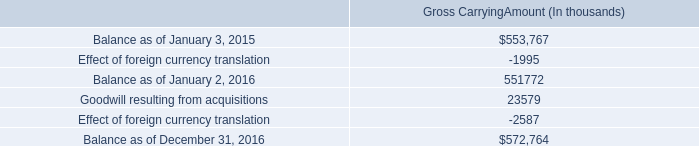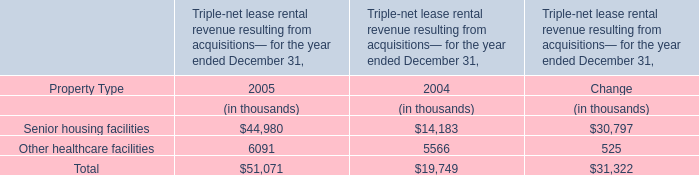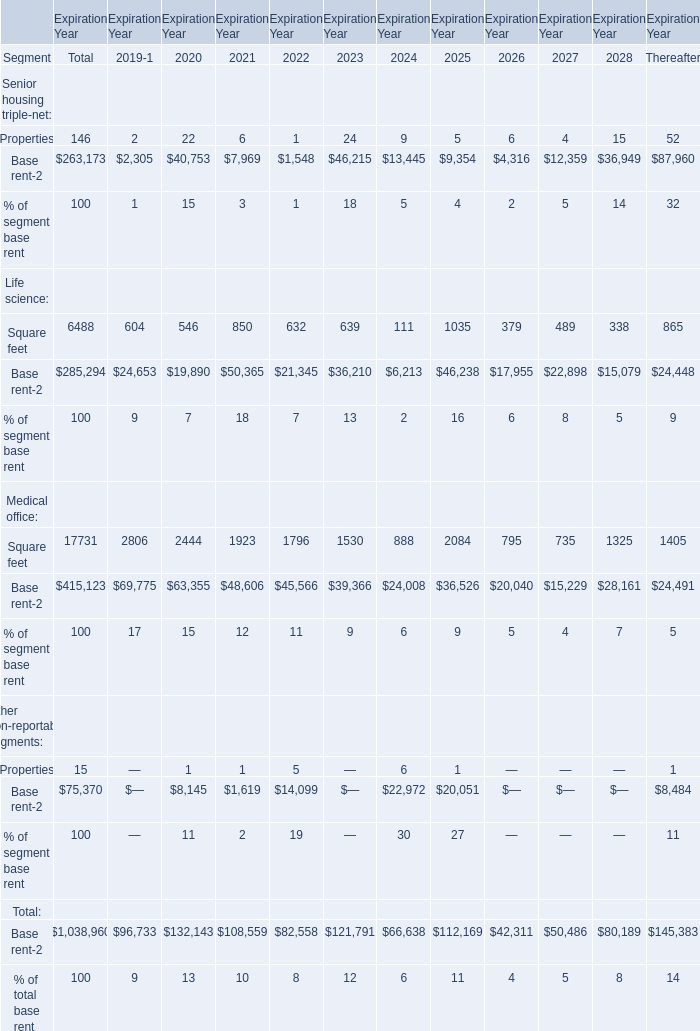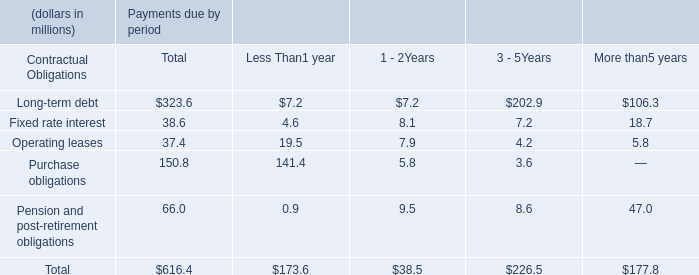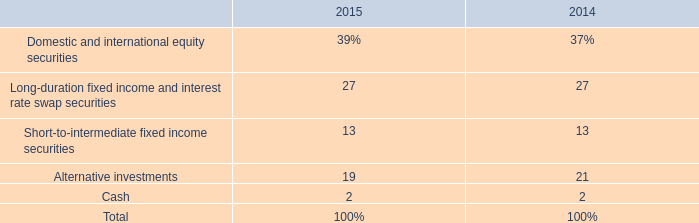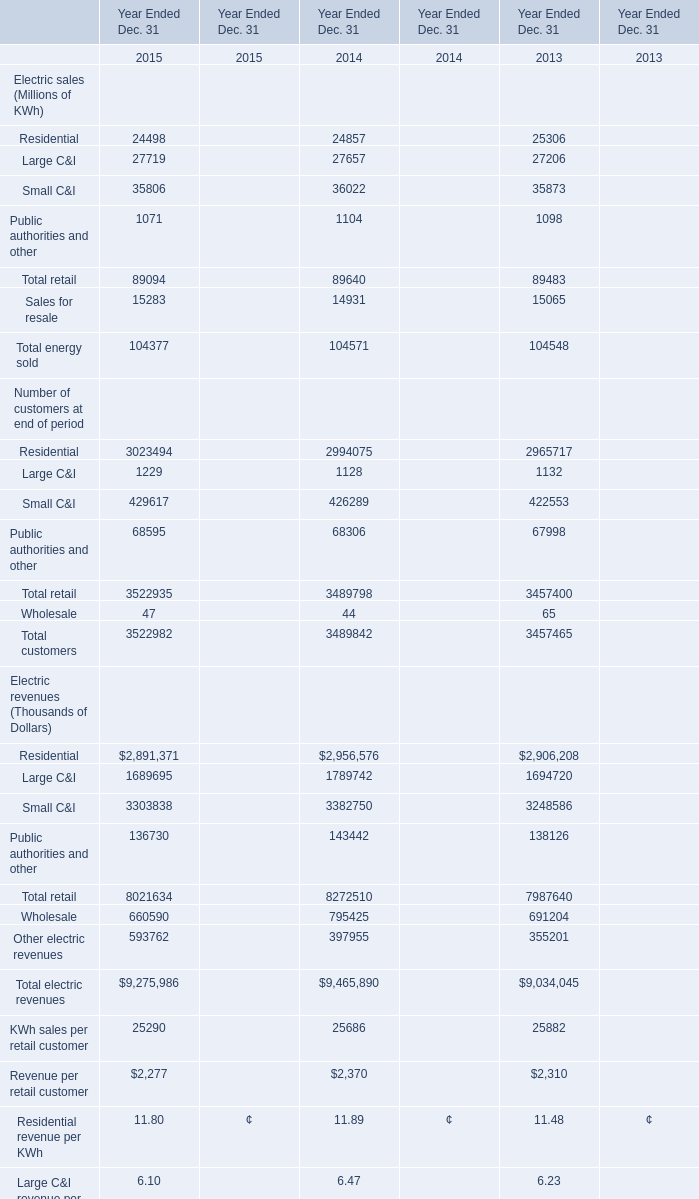In the year with lowest amount of Residential, what's the increasing rate of Total retail ? 
Computations: ((89094 - 89640) / 89094)
Answer: -0.00613. 